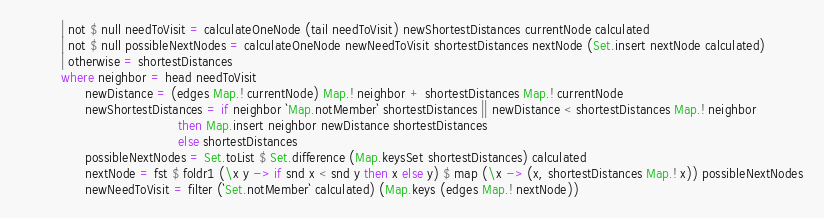Convert code to text. <code><loc_0><loc_0><loc_500><loc_500><_Haskell_>          | not $ null needToVisit = calculateOneNode (tail needToVisit) newShortestDistances currentNode calculated
          | not $ null possibleNextNodes = calculateOneNode newNeedToVisit shortestDistances nextNode (Set.insert nextNode calculated)
          | otherwise = shortestDistances
          where neighbor = head needToVisit
                newDistance = (edges Map.! currentNode) Map.! neighbor + shortestDistances Map.! currentNode
                newShortestDistances = if neighbor `Map.notMember` shortestDistances || newDistance < shortestDistances Map.! neighbor
                                       then Map.insert neighbor newDistance shortestDistances
                                       else shortestDistances
                possibleNextNodes = Set.toList $ Set.difference (Map.keysSet shortestDistances) calculated
                nextNode = fst $ foldr1 (\x y -> if snd x < snd y then x else y) $ map (\x -> (x, shortestDistances Map.! x)) possibleNextNodes
                newNeedToVisit = filter (`Set.notMember` calculated) (Map.keys (edges Map.! nextNode))
</code> 